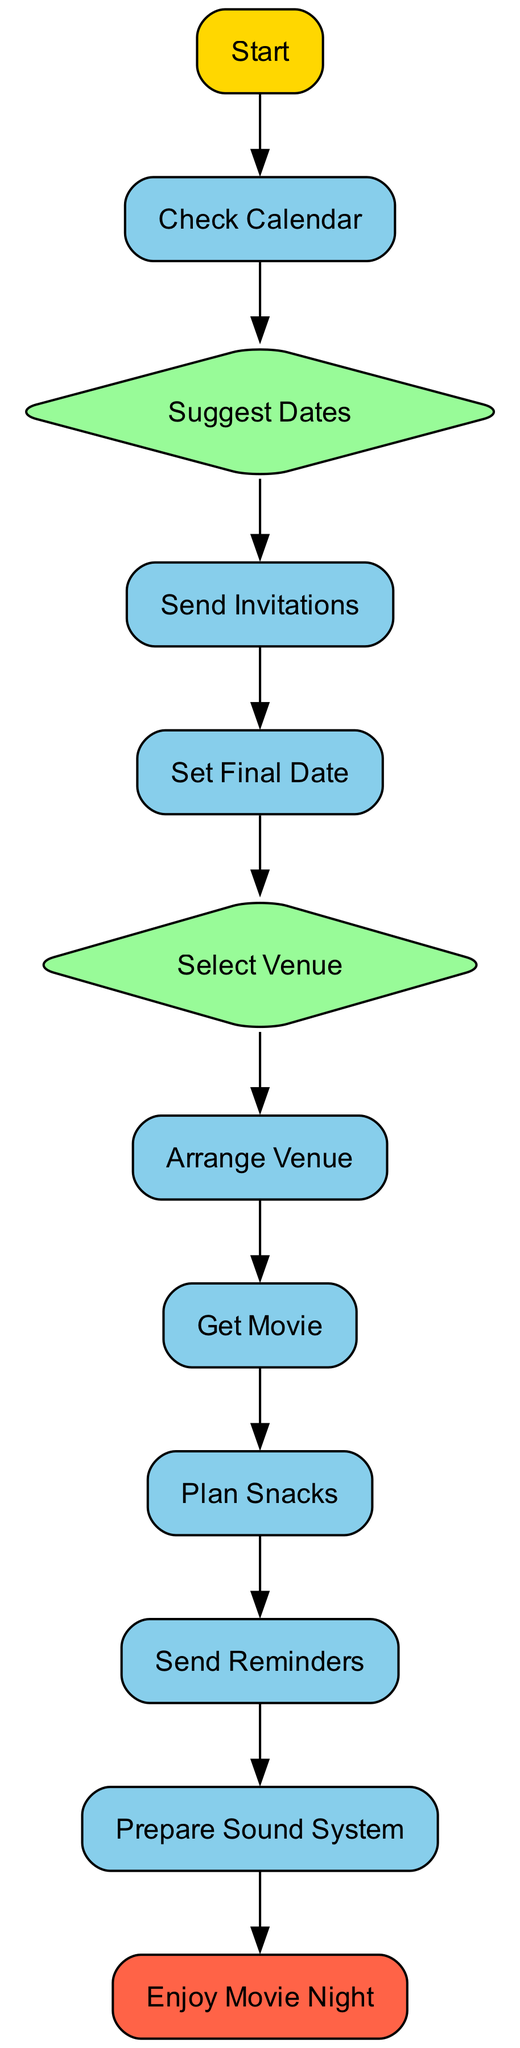What is the first step in the process? The first step in the flow chart is labeled "Start," which indicates the beginning of the movie night planning process.
Answer: Start How many decision nodes are in the flow chart? By reviewing the elements, there are 2 decision nodes: "Suggest Dates" and "Select Venue."
Answer: 2 Which node follows "Send Invitations"? The node that follows "Send Invitations" is "Set Final Date," indicating that once invitations are sent, the final date can be confirmed.
Answer: Set Final Date What does the node "Get Movie" ensure? The "Get Movie" node ensures that there is a copy of 'Coming to America,' either through streaming or on DVD, which is essential for the movie night.
Answer: A copy of 'Coming to America' What is the last action before "Enjoy Movie Night"? The last action before reaching "Enjoy Movie Night" is "Prepare Sound System," which ensures the sound setup is ready for the movie.
Answer: Prepare Sound System If the venue is selected, what must be arranged next? After selecting the venue, the next step is to "Arrange Venue," which involves setting up the space with comfortable seating and sound equipment.
Answer: Arrange Venue What are the two options in the "Select Venue" decision? The two options presented in the "Select Venue" node are your house or a friend’s house, indicating where the movie night can take place.
Answer: Your house or a friend’s house How do you finalize the date for the movie night? The final date for the movie night is confirmed in the "Set Final Date" process, based on responses from friends to the invitations sent out.
Answer: Based on friends' responses What task is performed on the day before the movie night? On the day before the movie night, the task performed is "Send Reminders," ensuring that all friends remember the event.
Answer: Send Reminders 